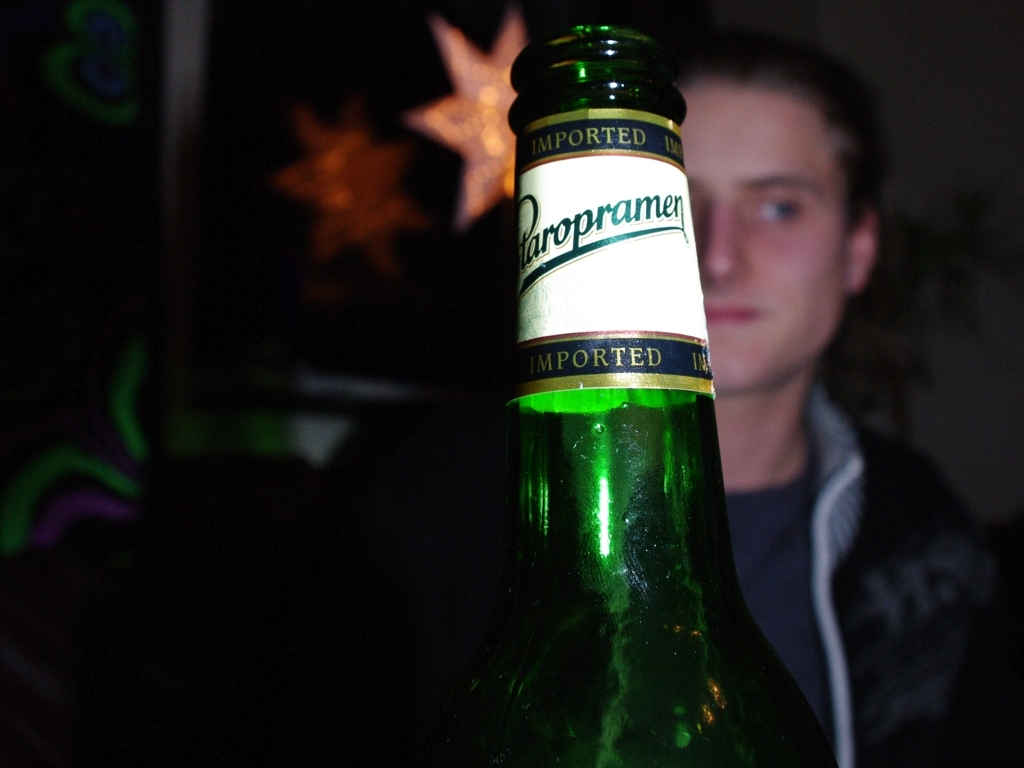What is the mood or atmosphere conveyed by this picture? The mood of the picture feels casual and relaxed, possibly capturing a moment at a social gathering, with the ambient lighting and blur suggesting a low-key, informal setting. 